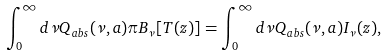Convert formula to latex. <formula><loc_0><loc_0><loc_500><loc_500>\int _ { 0 } ^ { \infty } d \nu Q _ { a b s } ( \nu , a ) \pi B _ { \nu } [ T ( z ) ] = \int _ { 0 } ^ { \infty } d \nu Q _ { a b s } ( \nu , a ) I _ { \nu } ( z ) ,</formula> 